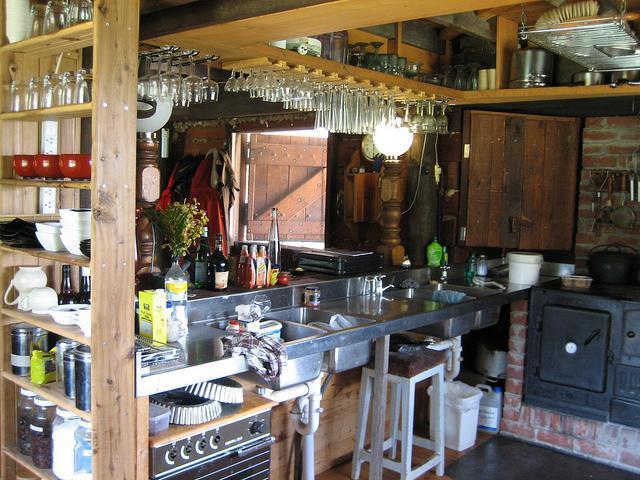How many bottles are in the photo?
Give a very brief answer. 1. How many laptops are visible?
Give a very brief answer. 0. 